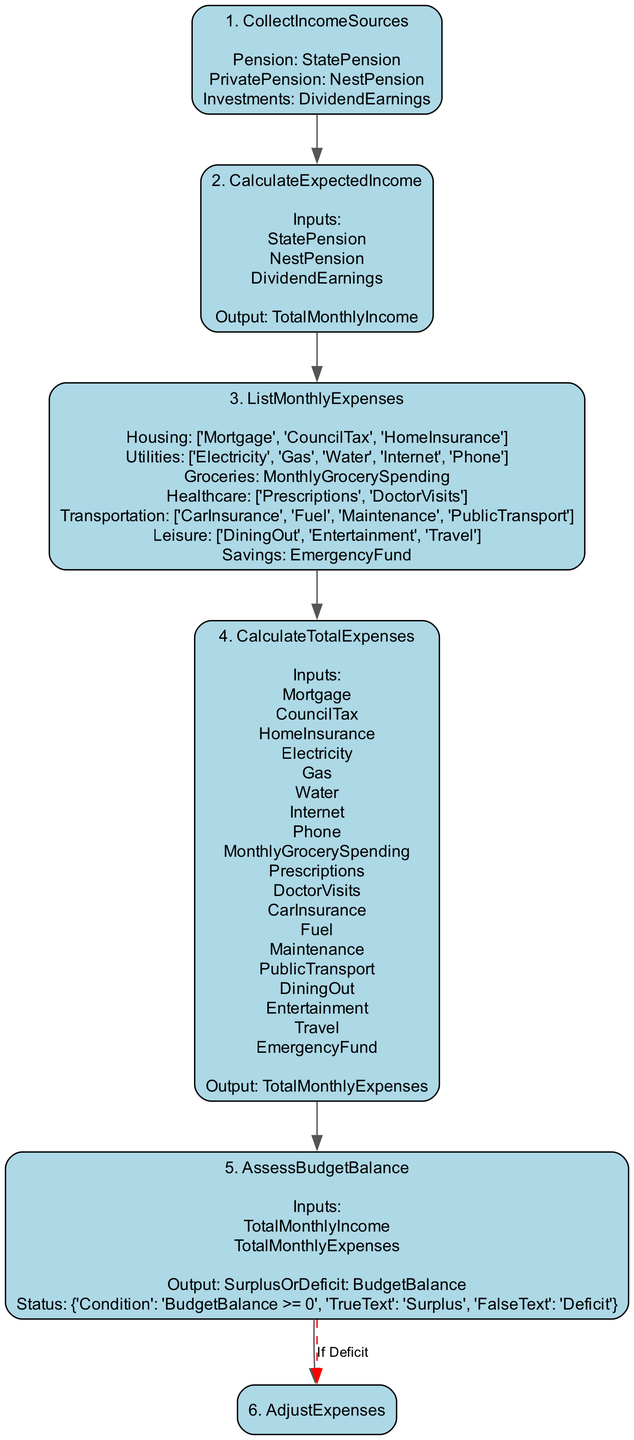What is the first step in the function? The first step in the function is labeled as "1. CollectIncomeSources". It states that the function collects various income sources which include the State Pension, Private Pension, and Investments.
Answer: CollectIncomeSources How many steps are there in the diagram? The diagram has a total of 6 steps. Each step is numerically labeled from 1 to 6, indicating their sequence in the function.
Answer: 6 What is the output of the "CalculateExpectedIncome" step? The output of the "CalculateExpectedIncome" step is labeled as "TotalMonthlyIncome". This is the total income calculated from the income sources collected prior.
Answer: TotalMonthlyIncome What does the "AssessBudgetBalance" step determine? The "AssessBudgetBalance" step determines the budget balance. It takes inputs of total monthly income and total monthly expenses to assess if there is a surplus or deficit.
Answer: Surplus or Deficit What condition leads to the "AdjustExpenses" step being executed? The "AdjustExpenses" step is executed when the "BudgetBalance" is less than zero, indicating a deficit. This prompts a review of the discretionary spending in certain categories.
Answer: BudgetBalance < 0 What is the relationship between the "CalculateTotalExpenses" and "AssessBudgetBalance" steps? The "CalculateTotalExpenses" step provides the total monthly expenses needed as input for the "AssessBudgetBalance" step. This relationship is crucial for determining if there is a surplus or deficit.
Answer: TotalMonthlyExpenses What categories are included in "ListMonthlyExpenses"? The "ListMonthlyExpenses" step includes the categories of Housing, Utilities, Groceries, Healthcare, Transportation, Leisure, and Savings. These categories outline where expenses will be recorded.
Answer: Housing, Utilities, Groceries, Healthcare, Transportation, Leisure, Savings What happens if the budget balance indicates a surplus? If the budget balance indicates a surplus, there are no further instructions or adjustments necessary in the "AdjustExpenses" step, and it denotes financial stability.
Answer: Surplus What type of expenses should be reviewed in case of a budget deficit? In case of a budget deficit, the instructions indicate to review and reduce discretionary spending specifically in the "Leisure" and "Travel" categories to help rectify the budget shortfall.
Answer: Leisure and Travel 